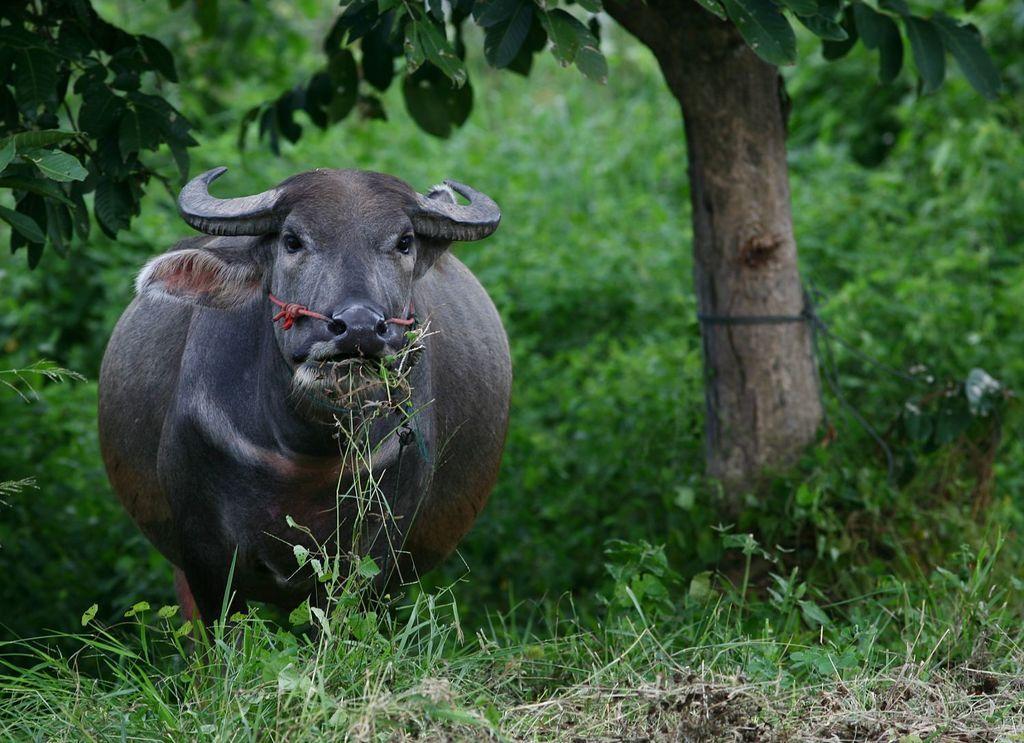Can you describe this image briefly? This picture contains a buffalo which is grazing the grass. At the bottom of the picture, we see grass and herbs. In the background, there are trees and herbs. 